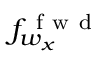Convert formula to latex. <formula><loc_0><loc_0><loc_500><loc_500>f _ { w _ { x } } ^ { f w d }</formula> 